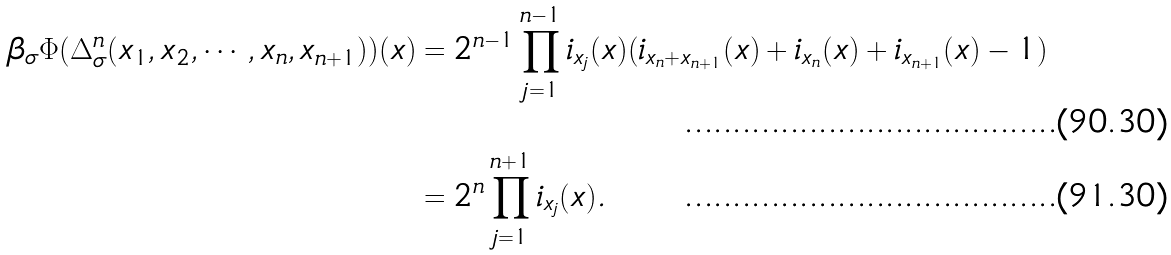<formula> <loc_0><loc_0><loc_500><loc_500>\beta _ { \sigma } \Phi ( \Delta _ { \sigma } ^ { n } ( x _ { 1 } , x _ { 2 } , \cdots , x _ { n } , x _ { n + 1 } ) ) ( x ) & = 2 ^ { n - 1 } \prod _ { j = 1 } ^ { n - 1 } i _ { x _ { j } } ( x ) ( i _ { x _ { n } + x _ { n + 1 } } ( x ) + i _ { x _ { n } } ( x ) + i _ { x _ { n + 1 } } ( x ) - 1 ) \\ & = 2 ^ { n } \prod _ { j = 1 } ^ { n + 1 } i _ { x _ { j } } ( x ) .</formula> 